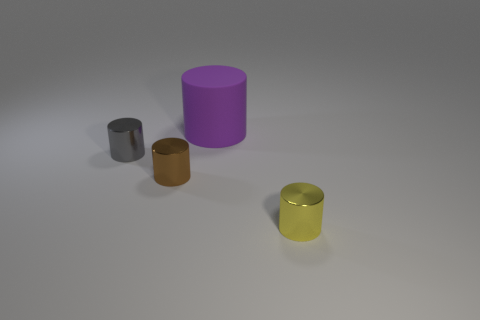How many objects are either small brown cylinders that are left of the large thing or small cyan rubber cubes?
Provide a succinct answer. 1. The purple rubber object is what shape?
Ensure brevity in your answer.  Cylinder. What color is the thing that is both in front of the large matte cylinder and on the right side of the tiny brown object?
Ensure brevity in your answer.  Yellow. There is a brown thing that is the same size as the gray thing; what shape is it?
Offer a terse response. Cylinder. Is there a small gray thing that has the same shape as the brown thing?
Your answer should be very brief. Yes. Are the tiny gray cylinder and the thing right of the large purple matte object made of the same material?
Your response must be concise. Yes. What color is the tiny metallic cylinder on the right side of the object that is behind the tiny gray metallic thing on the left side of the big thing?
Your response must be concise. Yellow. What material is the gray thing that is the same size as the brown object?
Your answer should be compact. Metal. What number of brown cylinders are made of the same material as the gray object?
Ensure brevity in your answer.  1. Does the metal cylinder that is right of the large cylinder have the same size as the cylinder to the left of the brown object?
Offer a very short reply. Yes. 